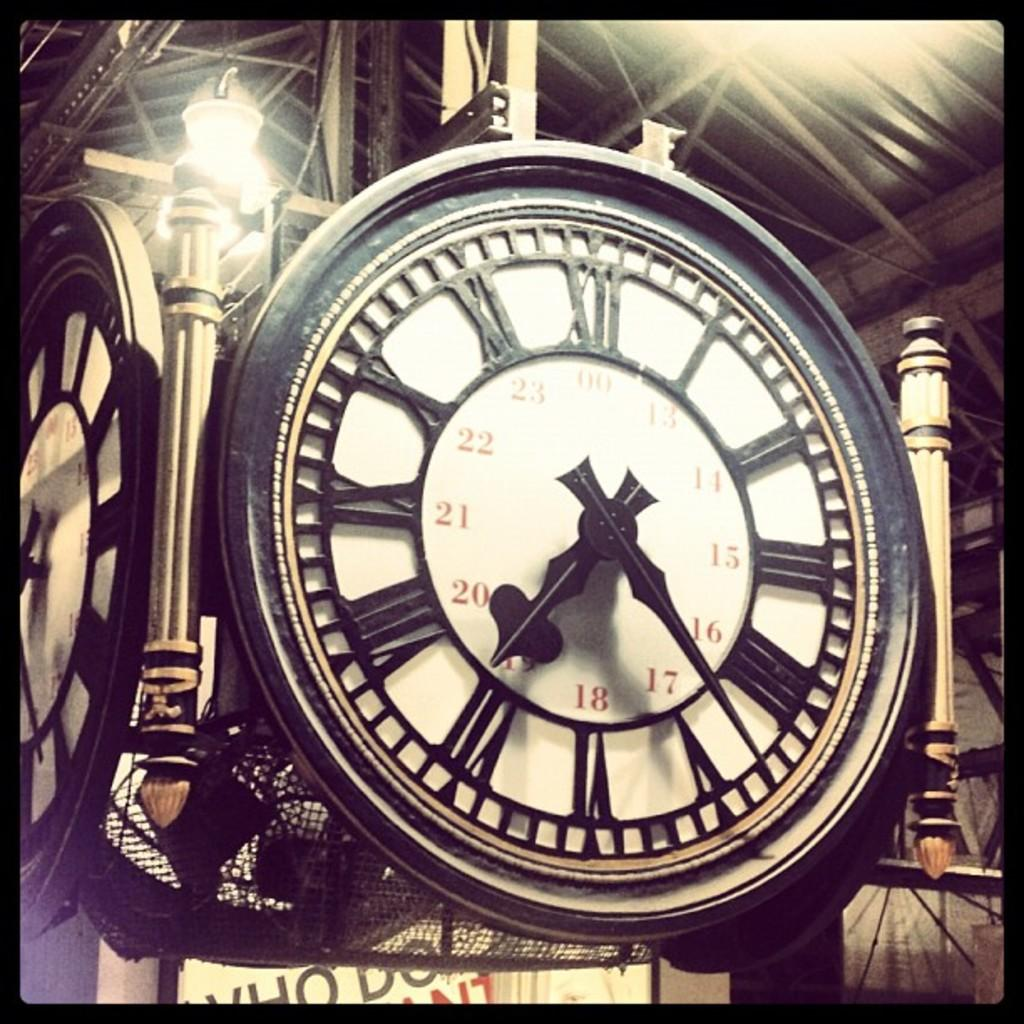<image>
Render a clear and concise summary of the photo. An old fashioned Roman numeral clock with Arabic numbers for the afternoon hours towards the centre of the clock. 